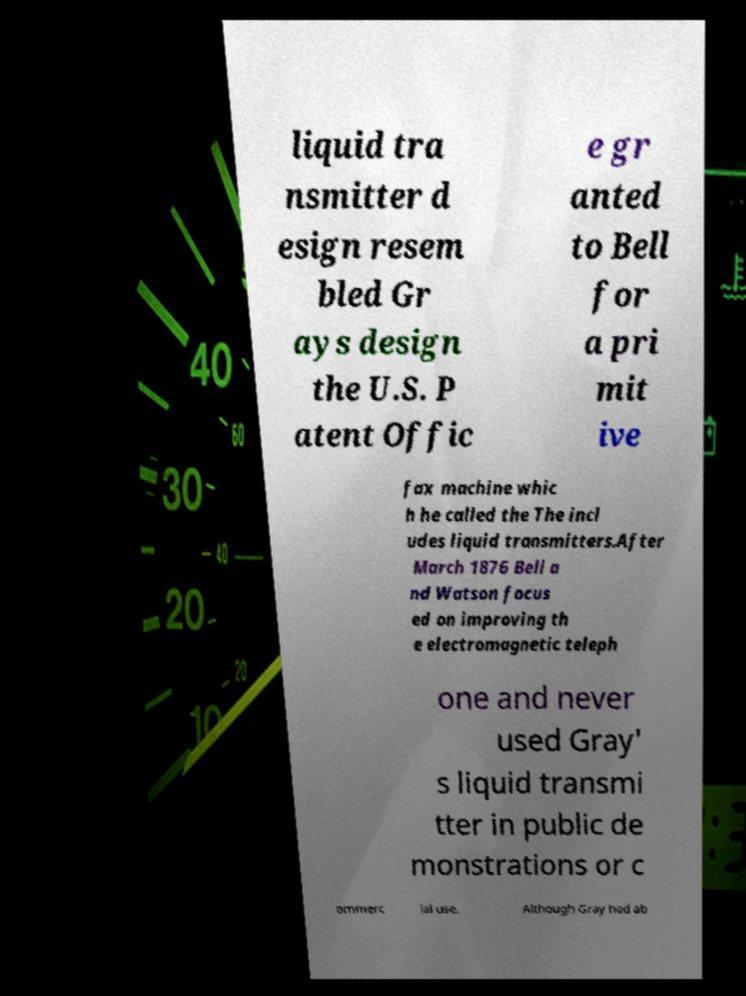For documentation purposes, I need the text within this image transcribed. Could you provide that? liquid tra nsmitter d esign resem bled Gr ays design the U.S. P atent Offic e gr anted to Bell for a pri mit ive fax machine whic h he called the The incl udes liquid transmitters.After March 1876 Bell a nd Watson focus ed on improving th e electromagnetic teleph one and never used Gray' s liquid transmi tter in public de monstrations or c ommerc ial use. Although Gray had ab 